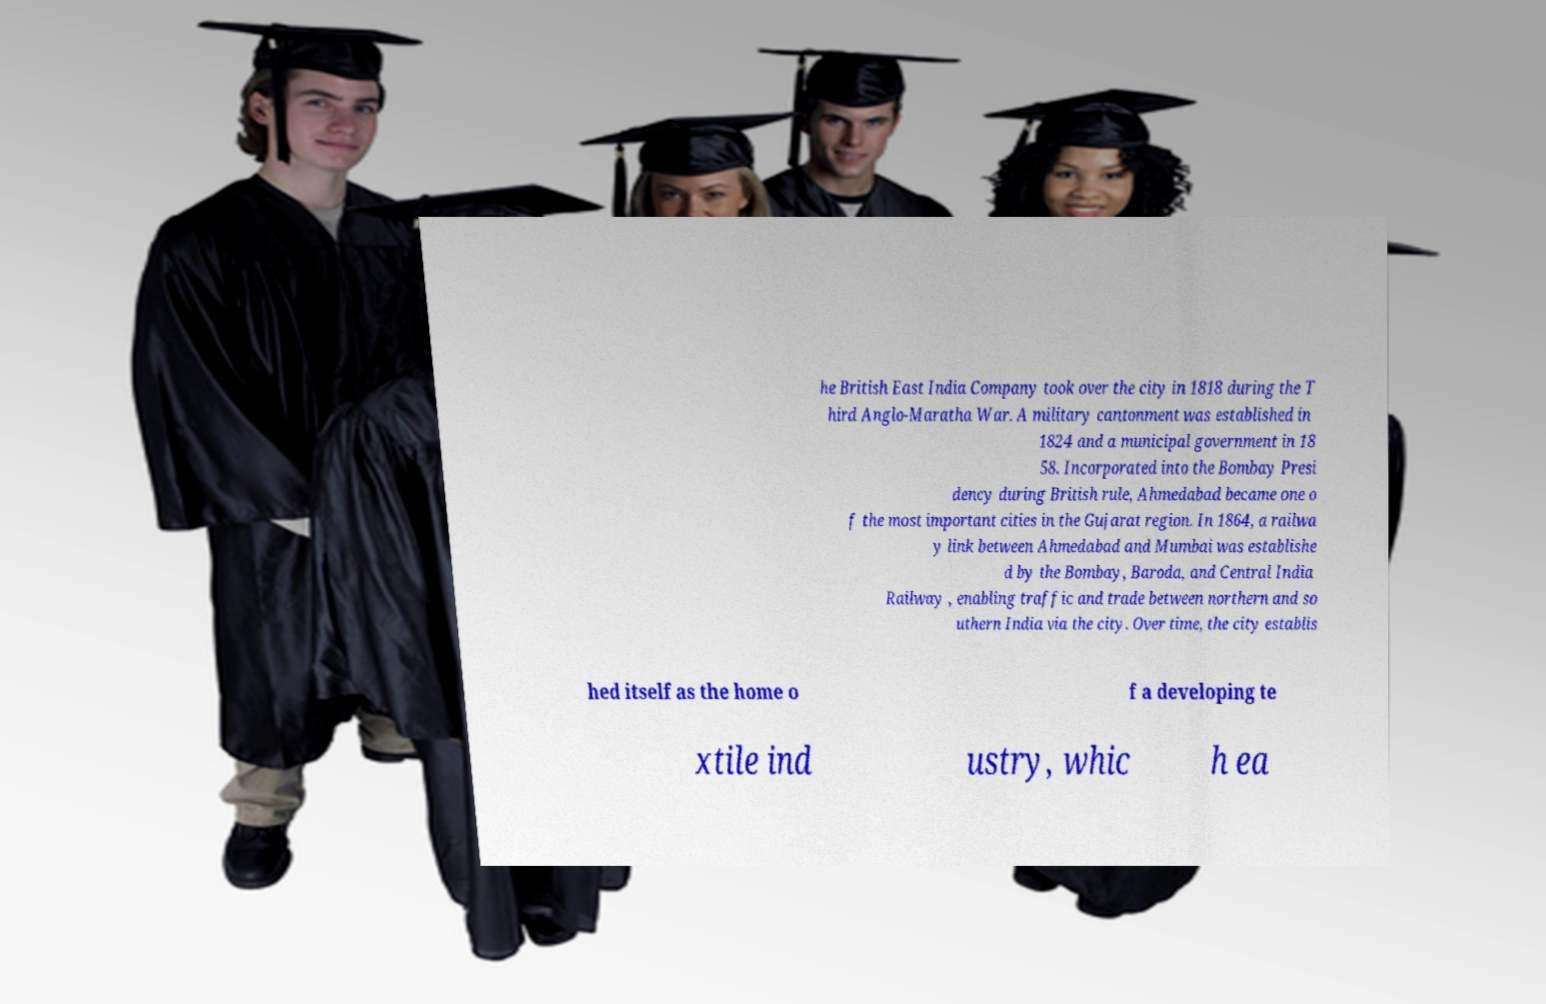What messages or text are displayed in this image? I need them in a readable, typed format. he British East India Company took over the city in 1818 during the T hird Anglo-Maratha War. A military cantonment was established in 1824 and a municipal government in 18 58. Incorporated into the Bombay Presi dency during British rule, Ahmedabad became one o f the most important cities in the Gujarat region. In 1864, a railwa y link between Ahmedabad and Mumbai was establishe d by the Bombay, Baroda, and Central India Railway , enabling traffic and trade between northern and so uthern India via the city. Over time, the city establis hed itself as the home o f a developing te xtile ind ustry, whic h ea 